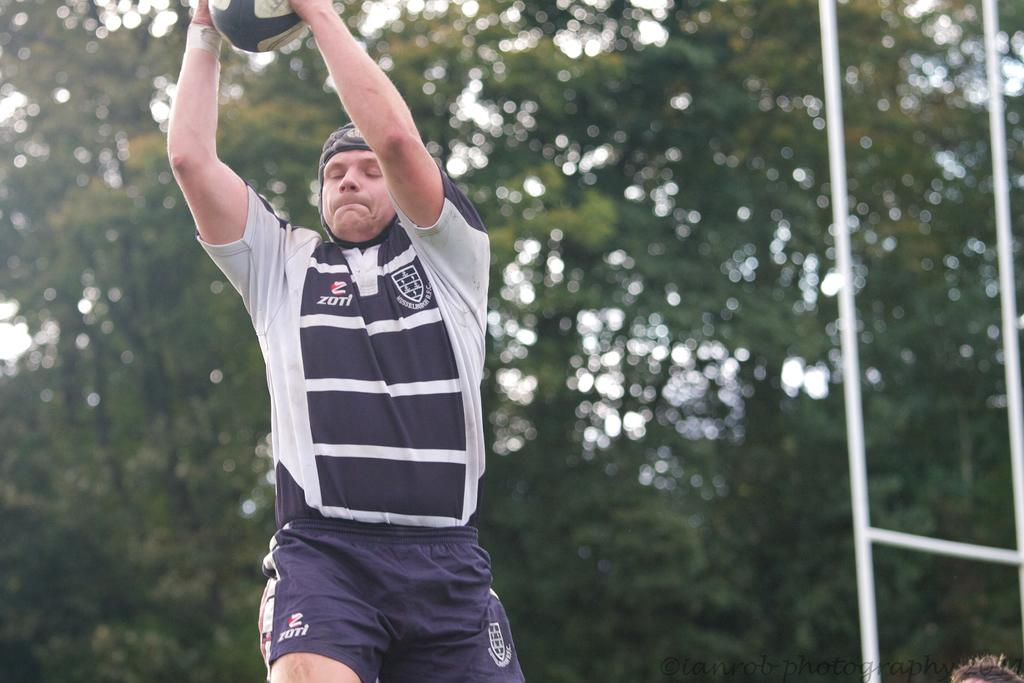<image>
Give a short and clear explanation of the subsequent image. A man wears a shirt that says Zotl on one side. 